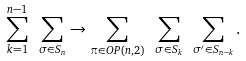Convert formula to latex. <formula><loc_0><loc_0><loc_500><loc_500>\sum _ { k = 1 } ^ { n - 1 } \ \sum _ { \sigma \in S _ { n } } \rightarrow \sum _ { \pi \in O P ( n , 2 ) } \ \sum _ { \sigma \in S _ { k } } \ \sum _ { \sigma ^ { \prime } \in S _ { n - k } } .</formula> 